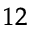Convert formula to latex. <formula><loc_0><loc_0><loc_500><loc_500>^ { 1 2 }</formula> 